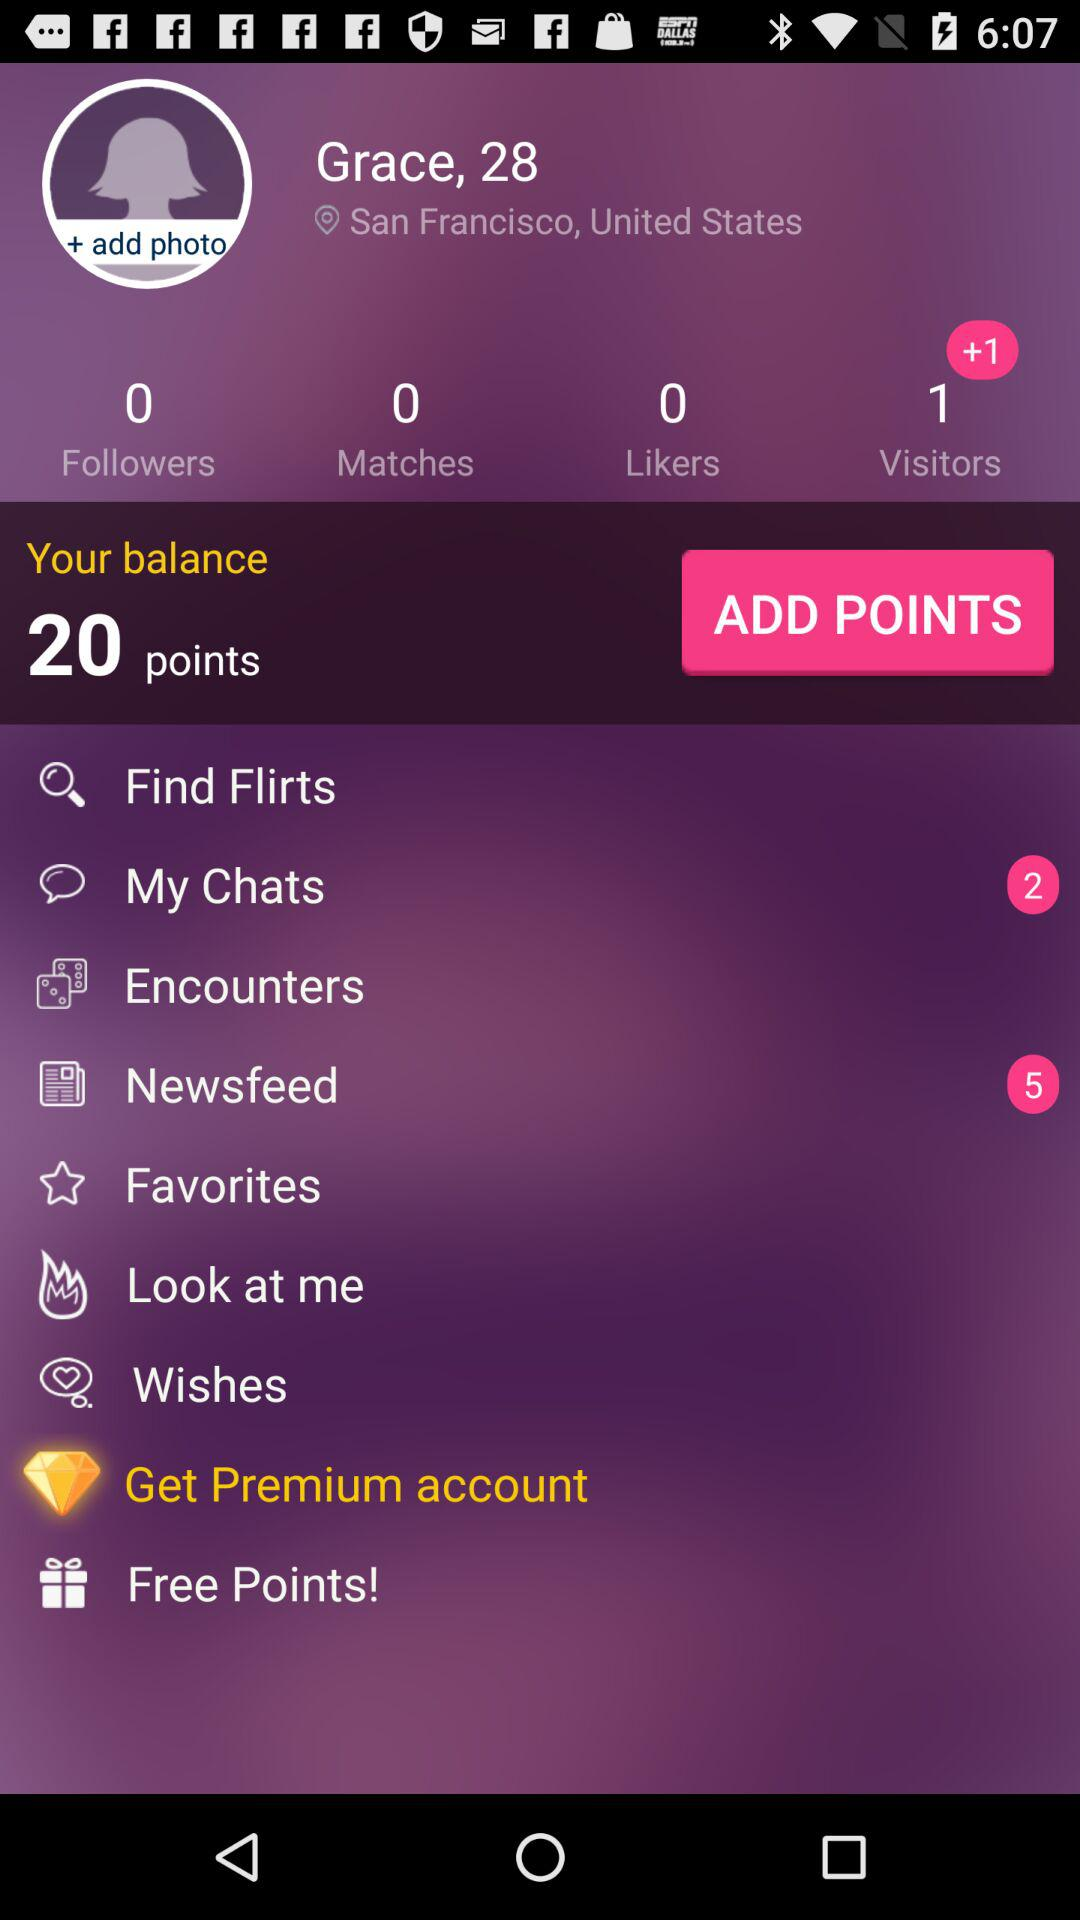What is the total number of points in the user's balance? The total number of points in the user's balance is 20. 